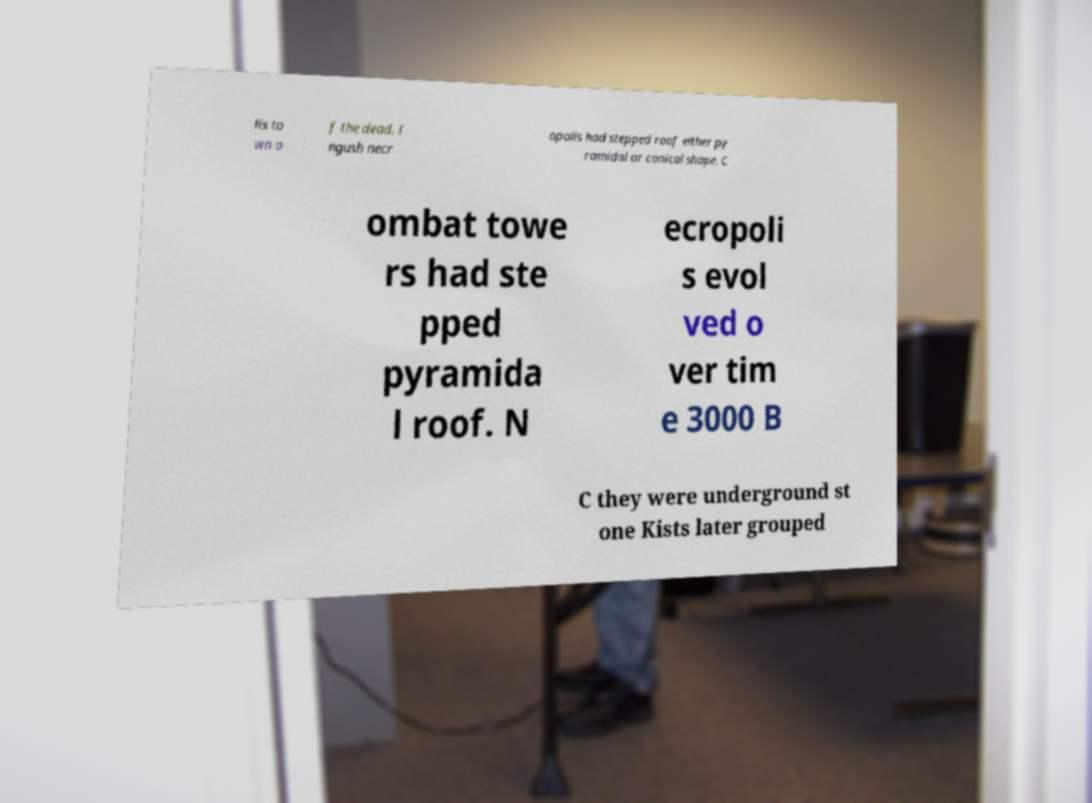Could you extract and type out the text from this image? lis to wn o f the dead. I ngush necr opolis had stepped roof either py ramidal or conical shape. C ombat towe rs had ste pped pyramida l roof. N ecropoli s evol ved o ver tim e 3000 B C they were underground st one Kists later grouped 